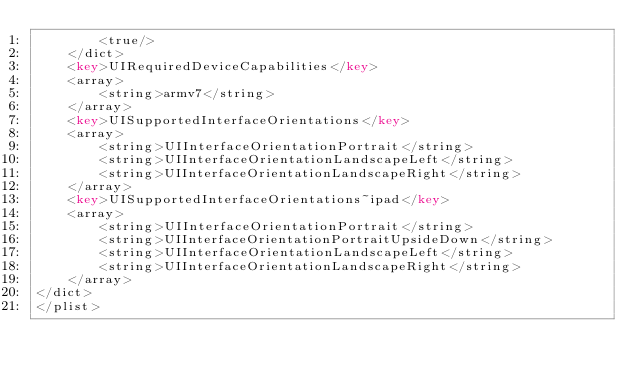Convert code to text. <code><loc_0><loc_0><loc_500><loc_500><_XML_>		<true/>
	</dict>
	<key>UIRequiredDeviceCapabilities</key>
	<array>
		<string>armv7</string>
	</array>
	<key>UISupportedInterfaceOrientations</key>
	<array>
		<string>UIInterfaceOrientationPortrait</string>
		<string>UIInterfaceOrientationLandscapeLeft</string>
		<string>UIInterfaceOrientationLandscapeRight</string>
	</array>
	<key>UISupportedInterfaceOrientations~ipad</key>
	<array>
		<string>UIInterfaceOrientationPortrait</string>
		<string>UIInterfaceOrientationPortraitUpsideDown</string>
		<string>UIInterfaceOrientationLandscapeLeft</string>
		<string>UIInterfaceOrientationLandscapeRight</string>
	</array>
</dict>
</plist>
</code> 